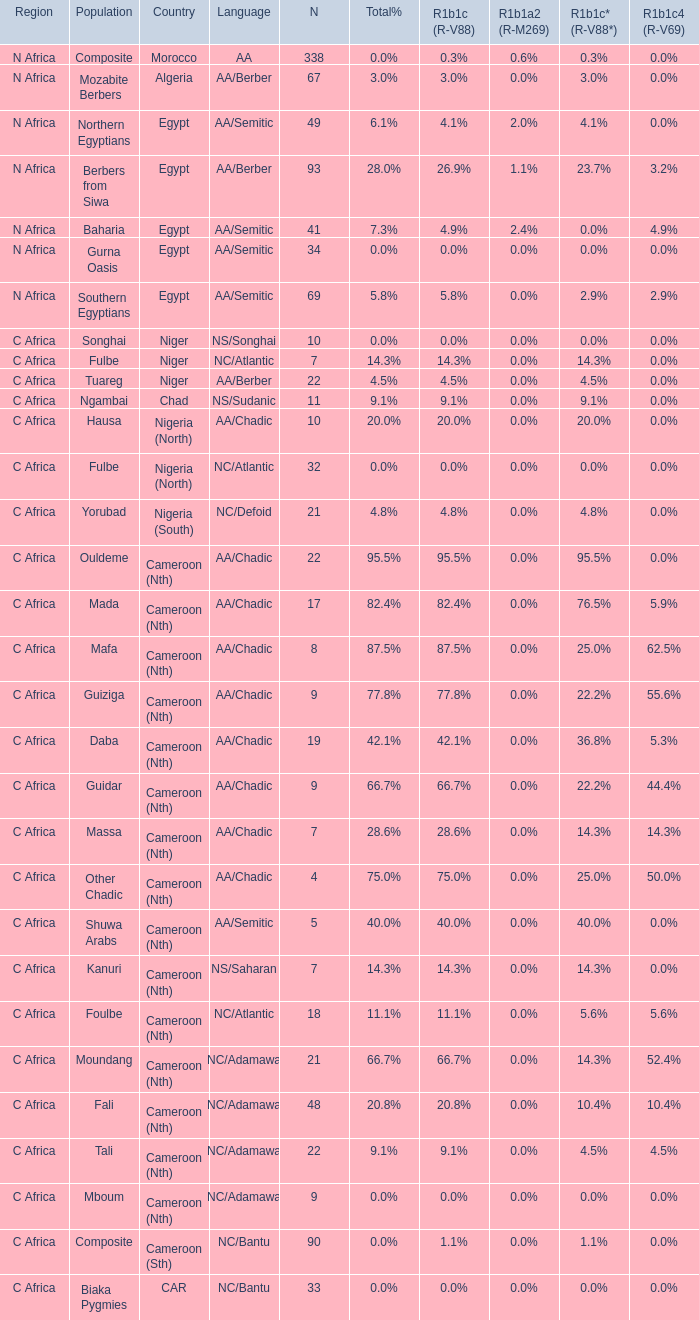What percentage is listed in column r1b1a2 (r-m269) for the 77.8% r1b1c (r-v88)? 0.0%. 